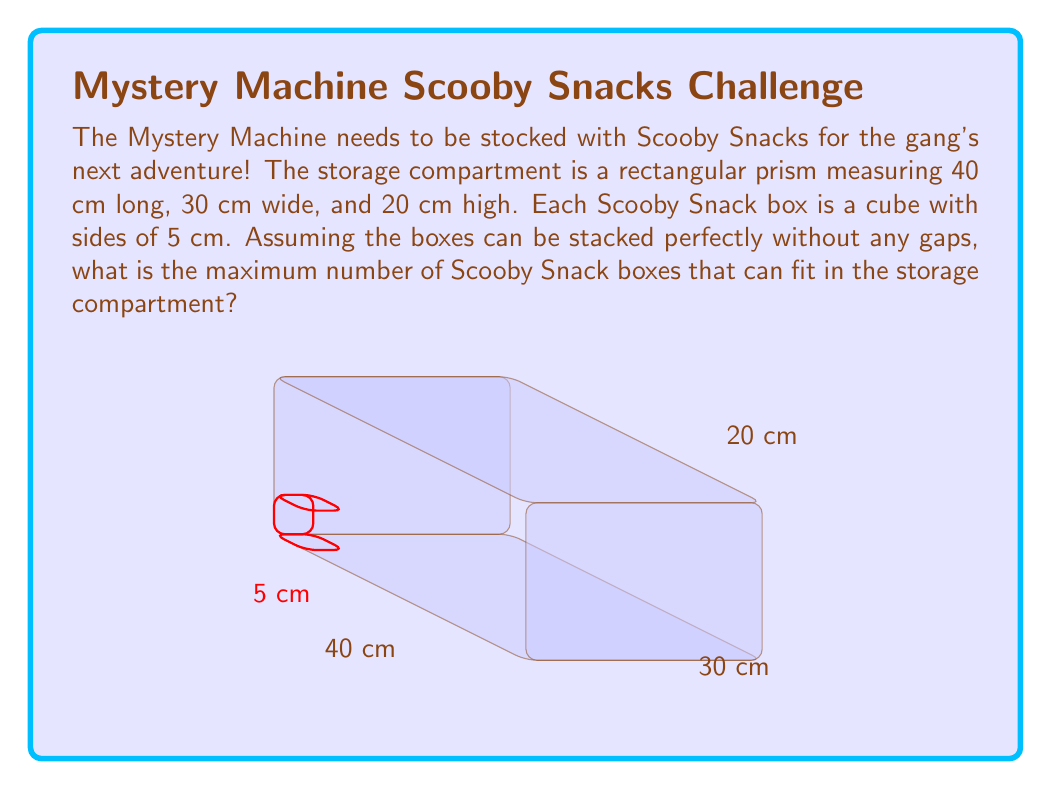Teach me how to tackle this problem. Let's approach this step-by-step:

1) First, we need to calculate how many Scooby Snack boxes can fit along each dimension of the storage compartment:

   Length: $\frac{40 \text{ cm}}{5 \text{ cm}} = 8$ boxes
   Width: $\frac{30 \text{ cm}}{5 \text{ cm}} = 6$ boxes
   Height: $\frac{20 \text{ cm}}{5 \text{ cm}} = 4$ boxes

2) Now, to find the total number of boxes that can fit, we multiply these numbers:

   $$\text{Total boxes} = 8 \times 6 \times 4$$

3) Let's calculate:

   $$\text{Total boxes} = 8 \times 6 \times 4 = 192$$

Therefore, the maximum number of Scooby Snack boxes that can fit in the storage compartment is 192.
Answer: 192 boxes 